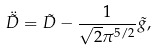Convert formula to latex. <formula><loc_0><loc_0><loc_500><loc_500>\ddot { \tilde { D } } = \tilde { D } - \frac { 1 } { \sqrt { 2 } \pi ^ { 5 / 2 } } \tilde { g } ,</formula> 